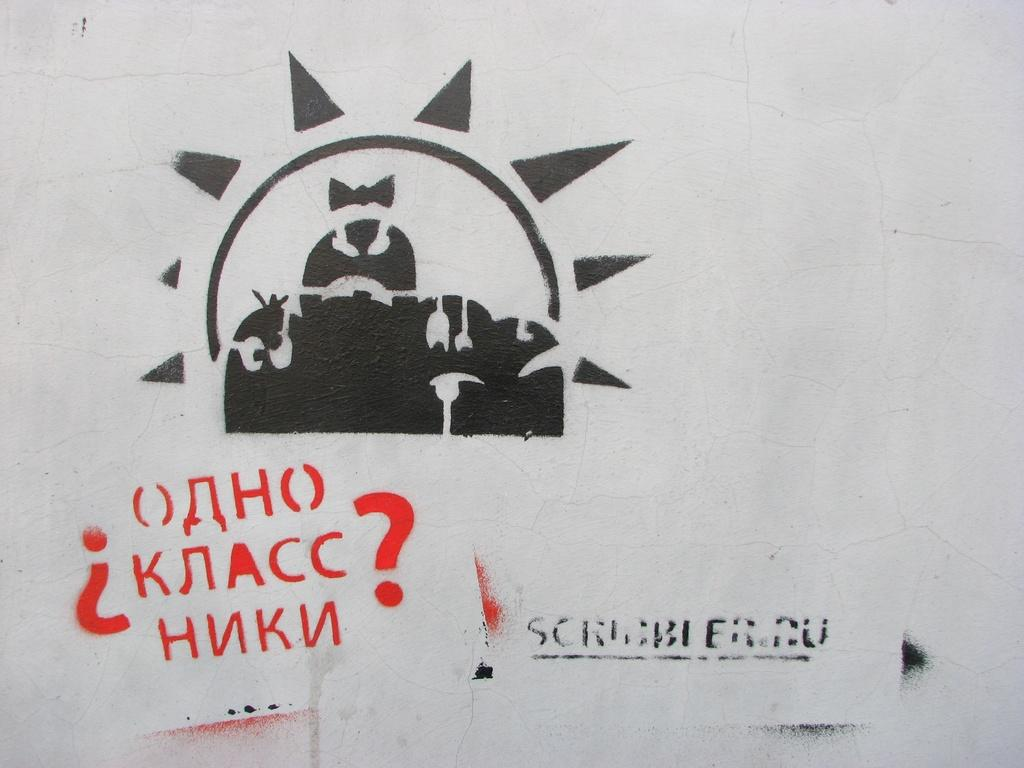What is on the wall in the image? There is a picture on the wall in the image. What else can be seen on the wall besides the picture? There is text written on the wall in the image. Is there a bear using the soap to clean the wall in the image? There is no bear or soap present in the image. What is the wealth status of the person who owns the wall in the image? The wealth status of the person who owns the wall cannot be determined from the image. 